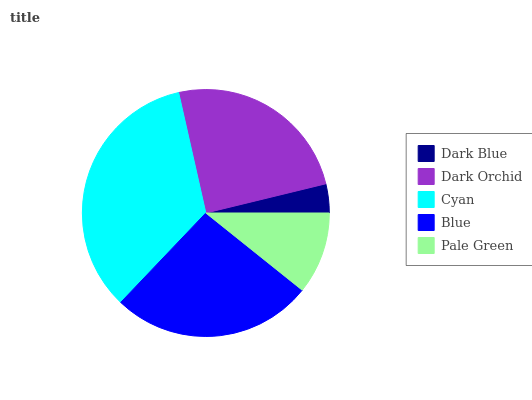Is Dark Blue the minimum?
Answer yes or no. Yes. Is Cyan the maximum?
Answer yes or no. Yes. Is Dark Orchid the minimum?
Answer yes or no. No. Is Dark Orchid the maximum?
Answer yes or no. No. Is Dark Orchid greater than Dark Blue?
Answer yes or no. Yes. Is Dark Blue less than Dark Orchid?
Answer yes or no. Yes. Is Dark Blue greater than Dark Orchid?
Answer yes or no. No. Is Dark Orchid less than Dark Blue?
Answer yes or no. No. Is Dark Orchid the high median?
Answer yes or no. Yes. Is Dark Orchid the low median?
Answer yes or no. Yes. Is Cyan the high median?
Answer yes or no. No. Is Cyan the low median?
Answer yes or no. No. 